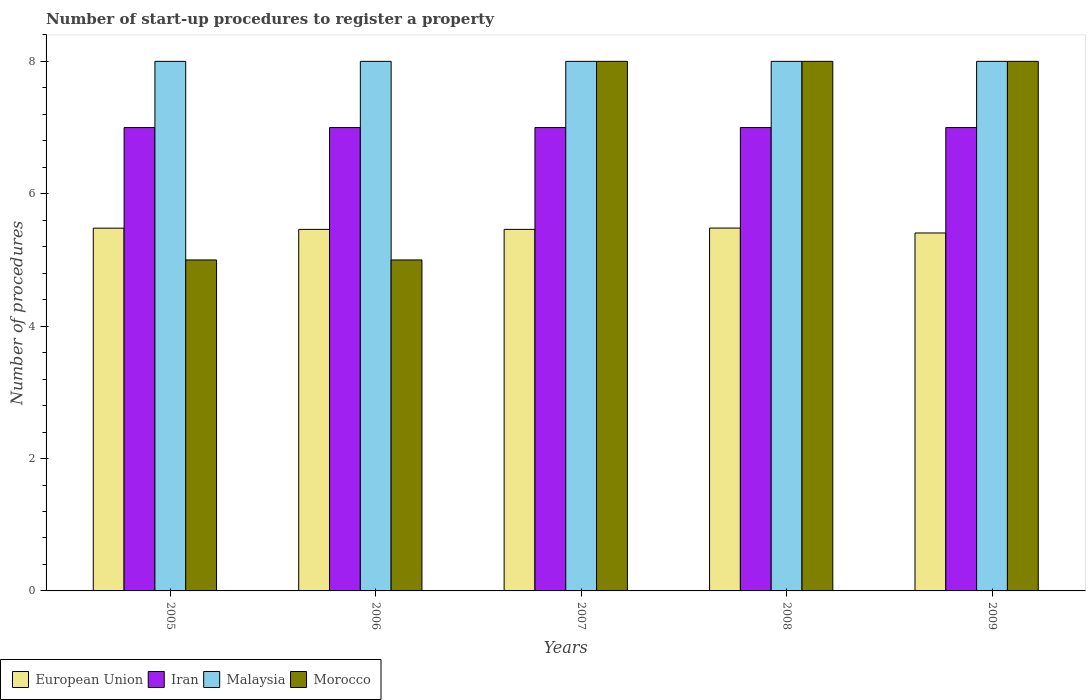How many different coloured bars are there?
Provide a succinct answer. 4. Are the number of bars on each tick of the X-axis equal?
Your response must be concise. Yes. How many bars are there on the 2nd tick from the right?
Give a very brief answer. 4. In how many cases, is the number of bars for a given year not equal to the number of legend labels?
Your response must be concise. 0. What is the number of procedures required to register a property in European Union in 2007?
Make the answer very short. 5.46. Across all years, what is the maximum number of procedures required to register a property in Malaysia?
Provide a short and direct response. 8. Across all years, what is the minimum number of procedures required to register a property in European Union?
Give a very brief answer. 5.41. What is the total number of procedures required to register a property in Malaysia in the graph?
Ensure brevity in your answer.  40. What is the difference between the number of procedures required to register a property in Malaysia in 2007 and the number of procedures required to register a property in European Union in 2009?
Give a very brief answer. 2.59. In the year 2005, what is the difference between the number of procedures required to register a property in Morocco and number of procedures required to register a property in Iran?
Ensure brevity in your answer.  -2. In how many years, is the number of procedures required to register a property in Malaysia greater than 4?
Keep it short and to the point. 5. Is the number of procedures required to register a property in European Union in 2005 less than that in 2009?
Your response must be concise. No. What is the difference between the highest and the second highest number of procedures required to register a property in European Union?
Give a very brief answer. 0. What is the difference between the highest and the lowest number of procedures required to register a property in European Union?
Give a very brief answer. 0.07. In how many years, is the number of procedures required to register a property in Morocco greater than the average number of procedures required to register a property in Morocco taken over all years?
Ensure brevity in your answer.  3. Is the sum of the number of procedures required to register a property in Morocco in 2006 and 2007 greater than the maximum number of procedures required to register a property in European Union across all years?
Ensure brevity in your answer.  Yes. Is it the case that in every year, the sum of the number of procedures required to register a property in Malaysia and number of procedures required to register a property in Iran is greater than the sum of number of procedures required to register a property in Morocco and number of procedures required to register a property in European Union?
Offer a very short reply. Yes. What does the 3rd bar from the left in 2009 represents?
Provide a short and direct response. Malaysia. What does the 3rd bar from the right in 2007 represents?
Ensure brevity in your answer.  Iran. Are all the bars in the graph horizontal?
Offer a terse response. No. What is the difference between two consecutive major ticks on the Y-axis?
Your response must be concise. 2. Does the graph contain any zero values?
Provide a succinct answer. No. Does the graph contain grids?
Ensure brevity in your answer.  No. Where does the legend appear in the graph?
Offer a terse response. Bottom left. What is the title of the graph?
Make the answer very short. Number of start-up procedures to register a property. What is the label or title of the Y-axis?
Offer a very short reply. Number of procedures. What is the Number of procedures of European Union in 2005?
Your answer should be very brief. 5.48. What is the Number of procedures of European Union in 2006?
Your answer should be compact. 5.46. What is the Number of procedures in Iran in 2006?
Your response must be concise. 7. What is the Number of procedures of Malaysia in 2006?
Give a very brief answer. 8. What is the Number of procedures in Morocco in 2006?
Keep it short and to the point. 5. What is the Number of procedures of European Union in 2007?
Make the answer very short. 5.46. What is the Number of procedures in Morocco in 2007?
Offer a terse response. 8. What is the Number of procedures of European Union in 2008?
Your answer should be very brief. 5.48. What is the Number of procedures in Iran in 2008?
Provide a short and direct response. 7. What is the Number of procedures of Morocco in 2008?
Your response must be concise. 8. What is the Number of procedures of European Union in 2009?
Offer a very short reply. 5.41. What is the Number of procedures of Iran in 2009?
Provide a succinct answer. 7. What is the Number of procedures in Malaysia in 2009?
Give a very brief answer. 8. Across all years, what is the maximum Number of procedures of European Union?
Ensure brevity in your answer.  5.48. Across all years, what is the maximum Number of procedures of Malaysia?
Offer a terse response. 8. Across all years, what is the minimum Number of procedures of European Union?
Offer a very short reply. 5.41. Across all years, what is the minimum Number of procedures in Malaysia?
Provide a succinct answer. 8. Across all years, what is the minimum Number of procedures in Morocco?
Offer a terse response. 5. What is the total Number of procedures in European Union in the graph?
Keep it short and to the point. 27.29. What is the total Number of procedures in Iran in the graph?
Provide a succinct answer. 35. What is the difference between the Number of procedures in European Union in 2005 and that in 2006?
Your answer should be compact. 0.02. What is the difference between the Number of procedures of Iran in 2005 and that in 2006?
Provide a short and direct response. 0. What is the difference between the Number of procedures of European Union in 2005 and that in 2007?
Provide a succinct answer. 0.02. What is the difference between the Number of procedures in Malaysia in 2005 and that in 2007?
Your answer should be very brief. 0. What is the difference between the Number of procedures of European Union in 2005 and that in 2008?
Offer a terse response. -0. What is the difference between the Number of procedures in European Union in 2005 and that in 2009?
Make the answer very short. 0.07. What is the difference between the Number of procedures of Iran in 2005 and that in 2009?
Ensure brevity in your answer.  0. What is the difference between the Number of procedures in European Union in 2006 and that in 2007?
Keep it short and to the point. 0. What is the difference between the Number of procedures of Iran in 2006 and that in 2007?
Ensure brevity in your answer.  0. What is the difference between the Number of procedures in European Union in 2006 and that in 2008?
Provide a succinct answer. -0.02. What is the difference between the Number of procedures in Iran in 2006 and that in 2008?
Make the answer very short. 0. What is the difference between the Number of procedures in Malaysia in 2006 and that in 2008?
Your response must be concise. 0. What is the difference between the Number of procedures of European Union in 2006 and that in 2009?
Keep it short and to the point. 0.05. What is the difference between the Number of procedures in Iran in 2006 and that in 2009?
Ensure brevity in your answer.  0. What is the difference between the Number of procedures in Malaysia in 2006 and that in 2009?
Make the answer very short. 0. What is the difference between the Number of procedures in European Union in 2007 and that in 2008?
Ensure brevity in your answer.  -0.02. What is the difference between the Number of procedures in Iran in 2007 and that in 2008?
Give a very brief answer. 0. What is the difference between the Number of procedures of Malaysia in 2007 and that in 2008?
Make the answer very short. 0. What is the difference between the Number of procedures of European Union in 2007 and that in 2009?
Offer a very short reply. 0.05. What is the difference between the Number of procedures in Iran in 2007 and that in 2009?
Your response must be concise. 0. What is the difference between the Number of procedures in European Union in 2008 and that in 2009?
Provide a short and direct response. 0.07. What is the difference between the Number of procedures in European Union in 2005 and the Number of procedures in Iran in 2006?
Ensure brevity in your answer.  -1.52. What is the difference between the Number of procedures of European Union in 2005 and the Number of procedures of Malaysia in 2006?
Offer a very short reply. -2.52. What is the difference between the Number of procedures in European Union in 2005 and the Number of procedures in Morocco in 2006?
Give a very brief answer. 0.48. What is the difference between the Number of procedures in Iran in 2005 and the Number of procedures in Malaysia in 2006?
Your answer should be compact. -1. What is the difference between the Number of procedures in European Union in 2005 and the Number of procedures in Iran in 2007?
Provide a succinct answer. -1.52. What is the difference between the Number of procedures of European Union in 2005 and the Number of procedures of Malaysia in 2007?
Provide a succinct answer. -2.52. What is the difference between the Number of procedures of European Union in 2005 and the Number of procedures of Morocco in 2007?
Ensure brevity in your answer.  -2.52. What is the difference between the Number of procedures of Iran in 2005 and the Number of procedures of Malaysia in 2007?
Keep it short and to the point. -1. What is the difference between the Number of procedures in European Union in 2005 and the Number of procedures in Iran in 2008?
Your answer should be very brief. -1.52. What is the difference between the Number of procedures of European Union in 2005 and the Number of procedures of Malaysia in 2008?
Your answer should be very brief. -2.52. What is the difference between the Number of procedures of European Union in 2005 and the Number of procedures of Morocco in 2008?
Provide a succinct answer. -2.52. What is the difference between the Number of procedures in Iran in 2005 and the Number of procedures in Malaysia in 2008?
Give a very brief answer. -1. What is the difference between the Number of procedures of European Union in 2005 and the Number of procedures of Iran in 2009?
Offer a terse response. -1.52. What is the difference between the Number of procedures of European Union in 2005 and the Number of procedures of Malaysia in 2009?
Make the answer very short. -2.52. What is the difference between the Number of procedures of European Union in 2005 and the Number of procedures of Morocco in 2009?
Provide a short and direct response. -2.52. What is the difference between the Number of procedures in Malaysia in 2005 and the Number of procedures in Morocco in 2009?
Make the answer very short. 0. What is the difference between the Number of procedures in European Union in 2006 and the Number of procedures in Iran in 2007?
Your answer should be very brief. -1.54. What is the difference between the Number of procedures of European Union in 2006 and the Number of procedures of Malaysia in 2007?
Offer a very short reply. -2.54. What is the difference between the Number of procedures in European Union in 2006 and the Number of procedures in Morocco in 2007?
Your answer should be compact. -2.54. What is the difference between the Number of procedures in Iran in 2006 and the Number of procedures in Malaysia in 2007?
Make the answer very short. -1. What is the difference between the Number of procedures in Iran in 2006 and the Number of procedures in Morocco in 2007?
Make the answer very short. -1. What is the difference between the Number of procedures in Malaysia in 2006 and the Number of procedures in Morocco in 2007?
Offer a very short reply. 0. What is the difference between the Number of procedures of European Union in 2006 and the Number of procedures of Iran in 2008?
Provide a short and direct response. -1.54. What is the difference between the Number of procedures of European Union in 2006 and the Number of procedures of Malaysia in 2008?
Provide a short and direct response. -2.54. What is the difference between the Number of procedures in European Union in 2006 and the Number of procedures in Morocco in 2008?
Offer a terse response. -2.54. What is the difference between the Number of procedures of Iran in 2006 and the Number of procedures of Malaysia in 2008?
Offer a very short reply. -1. What is the difference between the Number of procedures of Iran in 2006 and the Number of procedures of Morocco in 2008?
Provide a short and direct response. -1. What is the difference between the Number of procedures of Malaysia in 2006 and the Number of procedures of Morocco in 2008?
Keep it short and to the point. 0. What is the difference between the Number of procedures of European Union in 2006 and the Number of procedures of Iran in 2009?
Keep it short and to the point. -1.54. What is the difference between the Number of procedures in European Union in 2006 and the Number of procedures in Malaysia in 2009?
Your answer should be compact. -2.54. What is the difference between the Number of procedures in European Union in 2006 and the Number of procedures in Morocco in 2009?
Provide a succinct answer. -2.54. What is the difference between the Number of procedures of Iran in 2006 and the Number of procedures of Malaysia in 2009?
Provide a short and direct response. -1. What is the difference between the Number of procedures in Malaysia in 2006 and the Number of procedures in Morocco in 2009?
Give a very brief answer. 0. What is the difference between the Number of procedures in European Union in 2007 and the Number of procedures in Iran in 2008?
Offer a very short reply. -1.54. What is the difference between the Number of procedures of European Union in 2007 and the Number of procedures of Malaysia in 2008?
Your answer should be compact. -2.54. What is the difference between the Number of procedures in European Union in 2007 and the Number of procedures in Morocco in 2008?
Your answer should be very brief. -2.54. What is the difference between the Number of procedures of Iran in 2007 and the Number of procedures of Morocco in 2008?
Give a very brief answer. -1. What is the difference between the Number of procedures of Malaysia in 2007 and the Number of procedures of Morocco in 2008?
Offer a very short reply. 0. What is the difference between the Number of procedures in European Union in 2007 and the Number of procedures in Iran in 2009?
Provide a succinct answer. -1.54. What is the difference between the Number of procedures in European Union in 2007 and the Number of procedures in Malaysia in 2009?
Make the answer very short. -2.54. What is the difference between the Number of procedures of European Union in 2007 and the Number of procedures of Morocco in 2009?
Keep it short and to the point. -2.54. What is the difference between the Number of procedures in European Union in 2008 and the Number of procedures in Iran in 2009?
Provide a short and direct response. -1.52. What is the difference between the Number of procedures in European Union in 2008 and the Number of procedures in Malaysia in 2009?
Your response must be concise. -2.52. What is the difference between the Number of procedures of European Union in 2008 and the Number of procedures of Morocco in 2009?
Offer a very short reply. -2.52. What is the average Number of procedures of European Union per year?
Provide a short and direct response. 5.46. What is the average Number of procedures in Iran per year?
Ensure brevity in your answer.  7. What is the average Number of procedures in Malaysia per year?
Give a very brief answer. 8. In the year 2005, what is the difference between the Number of procedures of European Union and Number of procedures of Iran?
Offer a very short reply. -1.52. In the year 2005, what is the difference between the Number of procedures in European Union and Number of procedures in Malaysia?
Your answer should be compact. -2.52. In the year 2005, what is the difference between the Number of procedures in European Union and Number of procedures in Morocco?
Give a very brief answer. 0.48. In the year 2005, what is the difference between the Number of procedures of Iran and Number of procedures of Malaysia?
Provide a succinct answer. -1. In the year 2005, what is the difference between the Number of procedures in Malaysia and Number of procedures in Morocco?
Make the answer very short. 3. In the year 2006, what is the difference between the Number of procedures in European Union and Number of procedures in Iran?
Your answer should be compact. -1.54. In the year 2006, what is the difference between the Number of procedures of European Union and Number of procedures of Malaysia?
Give a very brief answer. -2.54. In the year 2006, what is the difference between the Number of procedures of European Union and Number of procedures of Morocco?
Ensure brevity in your answer.  0.46. In the year 2006, what is the difference between the Number of procedures of Iran and Number of procedures of Malaysia?
Keep it short and to the point. -1. In the year 2006, what is the difference between the Number of procedures of Iran and Number of procedures of Morocco?
Provide a succinct answer. 2. In the year 2007, what is the difference between the Number of procedures in European Union and Number of procedures in Iran?
Keep it short and to the point. -1.54. In the year 2007, what is the difference between the Number of procedures of European Union and Number of procedures of Malaysia?
Your response must be concise. -2.54. In the year 2007, what is the difference between the Number of procedures of European Union and Number of procedures of Morocco?
Ensure brevity in your answer.  -2.54. In the year 2007, what is the difference between the Number of procedures in Iran and Number of procedures in Malaysia?
Give a very brief answer. -1. In the year 2007, what is the difference between the Number of procedures of Iran and Number of procedures of Morocco?
Offer a very short reply. -1. In the year 2007, what is the difference between the Number of procedures of Malaysia and Number of procedures of Morocco?
Give a very brief answer. 0. In the year 2008, what is the difference between the Number of procedures in European Union and Number of procedures in Iran?
Give a very brief answer. -1.52. In the year 2008, what is the difference between the Number of procedures in European Union and Number of procedures in Malaysia?
Your response must be concise. -2.52. In the year 2008, what is the difference between the Number of procedures of European Union and Number of procedures of Morocco?
Keep it short and to the point. -2.52. In the year 2008, what is the difference between the Number of procedures in Malaysia and Number of procedures in Morocco?
Provide a short and direct response. 0. In the year 2009, what is the difference between the Number of procedures of European Union and Number of procedures of Iran?
Give a very brief answer. -1.59. In the year 2009, what is the difference between the Number of procedures of European Union and Number of procedures of Malaysia?
Your answer should be very brief. -2.59. In the year 2009, what is the difference between the Number of procedures in European Union and Number of procedures in Morocco?
Provide a short and direct response. -2.59. In the year 2009, what is the difference between the Number of procedures of Iran and Number of procedures of Malaysia?
Your answer should be compact. -1. In the year 2009, what is the difference between the Number of procedures in Iran and Number of procedures in Morocco?
Ensure brevity in your answer.  -1. What is the ratio of the Number of procedures of European Union in 2005 to that in 2006?
Offer a terse response. 1. What is the ratio of the Number of procedures in Morocco in 2005 to that in 2006?
Make the answer very short. 1. What is the ratio of the Number of procedures in Iran in 2005 to that in 2007?
Your response must be concise. 1. What is the ratio of the Number of procedures of European Union in 2005 to that in 2008?
Keep it short and to the point. 1. What is the ratio of the Number of procedures of Iran in 2005 to that in 2008?
Offer a terse response. 1. What is the ratio of the Number of procedures in Morocco in 2005 to that in 2008?
Offer a terse response. 0.62. What is the ratio of the Number of procedures of European Union in 2005 to that in 2009?
Provide a short and direct response. 1.01. What is the ratio of the Number of procedures in Iran in 2005 to that in 2009?
Your answer should be compact. 1. What is the ratio of the Number of procedures of Morocco in 2005 to that in 2009?
Your answer should be very brief. 0.62. What is the ratio of the Number of procedures of Malaysia in 2006 to that in 2007?
Your response must be concise. 1. What is the ratio of the Number of procedures of Iran in 2006 to that in 2008?
Offer a terse response. 1. What is the ratio of the Number of procedures of Morocco in 2006 to that in 2008?
Your response must be concise. 0.62. What is the ratio of the Number of procedures of European Union in 2006 to that in 2009?
Ensure brevity in your answer.  1.01. What is the ratio of the Number of procedures in Malaysia in 2006 to that in 2009?
Provide a succinct answer. 1. What is the ratio of the Number of procedures of Morocco in 2006 to that in 2009?
Keep it short and to the point. 0.62. What is the ratio of the Number of procedures in Iran in 2007 to that in 2008?
Your answer should be compact. 1. What is the ratio of the Number of procedures of European Union in 2007 to that in 2009?
Keep it short and to the point. 1.01. What is the ratio of the Number of procedures in Iran in 2007 to that in 2009?
Give a very brief answer. 1. What is the ratio of the Number of procedures in Morocco in 2007 to that in 2009?
Provide a succinct answer. 1. What is the ratio of the Number of procedures of European Union in 2008 to that in 2009?
Keep it short and to the point. 1.01. What is the difference between the highest and the second highest Number of procedures in European Union?
Provide a short and direct response. 0. What is the difference between the highest and the second highest Number of procedures of Malaysia?
Offer a very short reply. 0. What is the difference between the highest and the lowest Number of procedures in European Union?
Provide a short and direct response. 0.07. What is the difference between the highest and the lowest Number of procedures in Iran?
Keep it short and to the point. 0. 